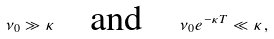Convert formula to latex. <formula><loc_0><loc_0><loc_500><loc_500>\nu _ { 0 } \gg \kappa \quad \text {and} \quad \nu _ { 0 } e ^ { - \kappa T } \ll \kappa \, ,</formula> 